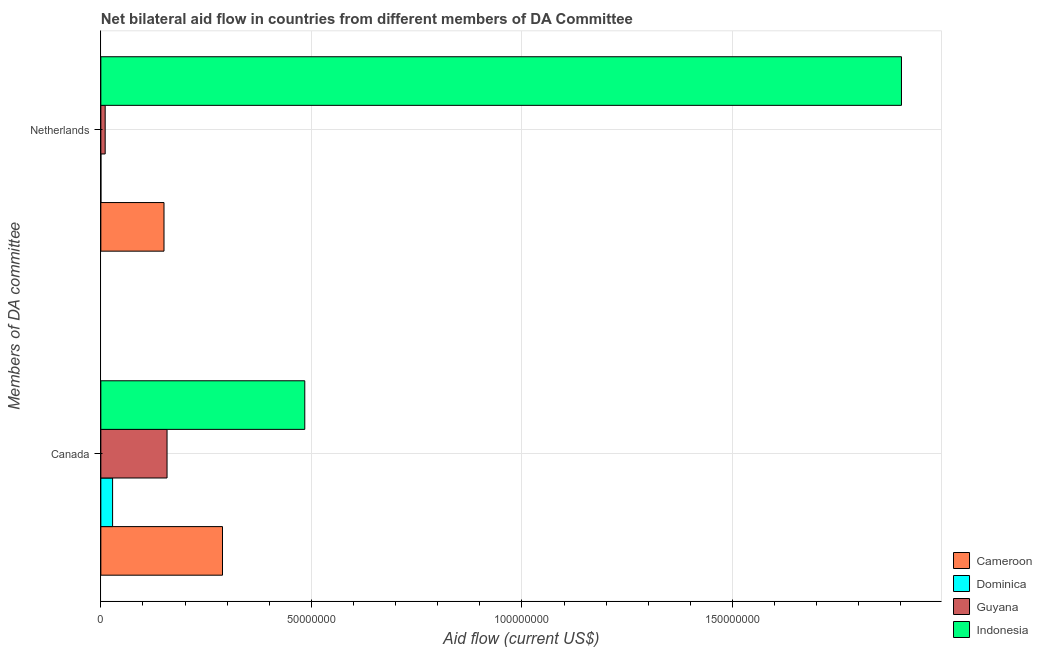How many groups of bars are there?
Offer a very short reply. 2. Are the number of bars per tick equal to the number of legend labels?
Your response must be concise. Yes. Are the number of bars on each tick of the Y-axis equal?
Make the answer very short. Yes. What is the label of the 1st group of bars from the top?
Provide a succinct answer. Netherlands. What is the amount of aid given by netherlands in Cameroon?
Provide a succinct answer. 1.50e+07. Across all countries, what is the maximum amount of aid given by netherlands?
Keep it short and to the point. 1.90e+08. Across all countries, what is the minimum amount of aid given by canada?
Give a very brief answer. 2.79e+06. In which country was the amount of aid given by canada minimum?
Your answer should be very brief. Dominica. What is the total amount of aid given by canada in the graph?
Ensure brevity in your answer.  9.58e+07. What is the difference between the amount of aid given by canada in Guyana and that in Indonesia?
Offer a very short reply. -3.27e+07. What is the difference between the amount of aid given by canada in Indonesia and the amount of aid given by netherlands in Dominica?
Keep it short and to the point. 4.84e+07. What is the average amount of aid given by netherlands per country?
Ensure brevity in your answer.  5.15e+07. What is the difference between the amount of aid given by canada and amount of aid given by netherlands in Guyana?
Keep it short and to the point. 1.47e+07. What is the ratio of the amount of aid given by netherlands in Dominica to that in Indonesia?
Offer a terse response. 5.259559248934939e-5. In how many countries, is the amount of aid given by netherlands greater than the average amount of aid given by netherlands taken over all countries?
Offer a very short reply. 1. What does the 2nd bar from the top in Canada represents?
Give a very brief answer. Guyana. What does the 1st bar from the bottom in Canada represents?
Make the answer very short. Cameroon. What is the difference between two consecutive major ticks on the X-axis?
Your response must be concise. 5.00e+07. Are the values on the major ticks of X-axis written in scientific E-notation?
Your answer should be very brief. No. Does the graph contain any zero values?
Ensure brevity in your answer.  No. What is the title of the graph?
Make the answer very short. Net bilateral aid flow in countries from different members of DA Committee. Does "Tajikistan" appear as one of the legend labels in the graph?
Your answer should be compact. No. What is the label or title of the X-axis?
Your answer should be very brief. Aid flow (current US$). What is the label or title of the Y-axis?
Provide a short and direct response. Members of DA committee. What is the Aid flow (current US$) in Cameroon in Canada?
Your answer should be compact. 2.89e+07. What is the Aid flow (current US$) of Dominica in Canada?
Provide a succinct answer. 2.79e+06. What is the Aid flow (current US$) of Guyana in Canada?
Offer a terse response. 1.57e+07. What is the Aid flow (current US$) of Indonesia in Canada?
Offer a terse response. 4.84e+07. What is the Aid flow (current US$) of Cameroon in Netherlands?
Offer a terse response. 1.50e+07. What is the Aid flow (current US$) of Dominica in Netherlands?
Your response must be concise. 10000. What is the Aid flow (current US$) in Guyana in Netherlands?
Offer a very short reply. 1.03e+06. What is the Aid flow (current US$) of Indonesia in Netherlands?
Provide a succinct answer. 1.90e+08. Across all Members of DA committee, what is the maximum Aid flow (current US$) in Cameroon?
Give a very brief answer. 2.89e+07. Across all Members of DA committee, what is the maximum Aid flow (current US$) in Dominica?
Your answer should be very brief. 2.79e+06. Across all Members of DA committee, what is the maximum Aid flow (current US$) in Guyana?
Your answer should be very brief. 1.57e+07. Across all Members of DA committee, what is the maximum Aid flow (current US$) in Indonesia?
Provide a succinct answer. 1.90e+08. Across all Members of DA committee, what is the minimum Aid flow (current US$) in Cameroon?
Your answer should be compact. 1.50e+07. Across all Members of DA committee, what is the minimum Aid flow (current US$) of Guyana?
Make the answer very short. 1.03e+06. Across all Members of DA committee, what is the minimum Aid flow (current US$) in Indonesia?
Provide a short and direct response. 4.84e+07. What is the total Aid flow (current US$) in Cameroon in the graph?
Provide a short and direct response. 4.39e+07. What is the total Aid flow (current US$) of Dominica in the graph?
Offer a terse response. 2.80e+06. What is the total Aid flow (current US$) in Guyana in the graph?
Provide a short and direct response. 1.68e+07. What is the total Aid flow (current US$) of Indonesia in the graph?
Give a very brief answer. 2.39e+08. What is the difference between the Aid flow (current US$) of Cameroon in Canada and that in Netherlands?
Give a very brief answer. 1.39e+07. What is the difference between the Aid flow (current US$) in Dominica in Canada and that in Netherlands?
Your answer should be very brief. 2.78e+06. What is the difference between the Aid flow (current US$) of Guyana in Canada and that in Netherlands?
Provide a succinct answer. 1.47e+07. What is the difference between the Aid flow (current US$) of Indonesia in Canada and that in Netherlands?
Your answer should be very brief. -1.42e+08. What is the difference between the Aid flow (current US$) in Cameroon in Canada and the Aid flow (current US$) in Dominica in Netherlands?
Your answer should be very brief. 2.89e+07. What is the difference between the Aid flow (current US$) in Cameroon in Canada and the Aid flow (current US$) in Guyana in Netherlands?
Provide a succinct answer. 2.79e+07. What is the difference between the Aid flow (current US$) of Cameroon in Canada and the Aid flow (current US$) of Indonesia in Netherlands?
Your answer should be compact. -1.61e+08. What is the difference between the Aid flow (current US$) of Dominica in Canada and the Aid flow (current US$) of Guyana in Netherlands?
Provide a succinct answer. 1.76e+06. What is the difference between the Aid flow (current US$) of Dominica in Canada and the Aid flow (current US$) of Indonesia in Netherlands?
Give a very brief answer. -1.87e+08. What is the difference between the Aid flow (current US$) of Guyana in Canada and the Aid flow (current US$) of Indonesia in Netherlands?
Your response must be concise. -1.74e+08. What is the average Aid flow (current US$) in Cameroon per Members of DA committee?
Offer a very short reply. 2.19e+07. What is the average Aid flow (current US$) in Dominica per Members of DA committee?
Your response must be concise. 1.40e+06. What is the average Aid flow (current US$) in Guyana per Members of DA committee?
Make the answer very short. 8.38e+06. What is the average Aid flow (current US$) in Indonesia per Members of DA committee?
Offer a very short reply. 1.19e+08. What is the difference between the Aid flow (current US$) of Cameroon and Aid flow (current US$) of Dominica in Canada?
Your answer should be compact. 2.61e+07. What is the difference between the Aid flow (current US$) of Cameroon and Aid flow (current US$) of Guyana in Canada?
Provide a short and direct response. 1.32e+07. What is the difference between the Aid flow (current US$) in Cameroon and Aid flow (current US$) in Indonesia in Canada?
Give a very brief answer. -1.95e+07. What is the difference between the Aid flow (current US$) of Dominica and Aid flow (current US$) of Guyana in Canada?
Provide a short and direct response. -1.29e+07. What is the difference between the Aid flow (current US$) in Dominica and Aid flow (current US$) in Indonesia in Canada?
Your answer should be compact. -4.56e+07. What is the difference between the Aid flow (current US$) in Guyana and Aid flow (current US$) in Indonesia in Canada?
Ensure brevity in your answer.  -3.27e+07. What is the difference between the Aid flow (current US$) in Cameroon and Aid flow (current US$) in Dominica in Netherlands?
Your response must be concise. 1.50e+07. What is the difference between the Aid flow (current US$) of Cameroon and Aid flow (current US$) of Guyana in Netherlands?
Offer a very short reply. 1.40e+07. What is the difference between the Aid flow (current US$) in Cameroon and Aid flow (current US$) in Indonesia in Netherlands?
Provide a succinct answer. -1.75e+08. What is the difference between the Aid flow (current US$) in Dominica and Aid flow (current US$) in Guyana in Netherlands?
Provide a short and direct response. -1.02e+06. What is the difference between the Aid flow (current US$) of Dominica and Aid flow (current US$) of Indonesia in Netherlands?
Your answer should be compact. -1.90e+08. What is the difference between the Aid flow (current US$) in Guyana and Aid flow (current US$) in Indonesia in Netherlands?
Give a very brief answer. -1.89e+08. What is the ratio of the Aid flow (current US$) of Cameroon in Canada to that in Netherlands?
Your response must be concise. 1.93. What is the ratio of the Aid flow (current US$) in Dominica in Canada to that in Netherlands?
Provide a succinct answer. 279. What is the ratio of the Aid flow (current US$) in Guyana in Canada to that in Netherlands?
Keep it short and to the point. 15.26. What is the ratio of the Aid flow (current US$) in Indonesia in Canada to that in Netherlands?
Ensure brevity in your answer.  0.25. What is the difference between the highest and the second highest Aid flow (current US$) in Cameroon?
Give a very brief answer. 1.39e+07. What is the difference between the highest and the second highest Aid flow (current US$) of Dominica?
Your answer should be compact. 2.78e+06. What is the difference between the highest and the second highest Aid flow (current US$) in Guyana?
Keep it short and to the point. 1.47e+07. What is the difference between the highest and the second highest Aid flow (current US$) of Indonesia?
Offer a terse response. 1.42e+08. What is the difference between the highest and the lowest Aid flow (current US$) in Cameroon?
Your answer should be very brief. 1.39e+07. What is the difference between the highest and the lowest Aid flow (current US$) in Dominica?
Your response must be concise. 2.78e+06. What is the difference between the highest and the lowest Aid flow (current US$) of Guyana?
Your response must be concise. 1.47e+07. What is the difference between the highest and the lowest Aid flow (current US$) of Indonesia?
Your response must be concise. 1.42e+08. 